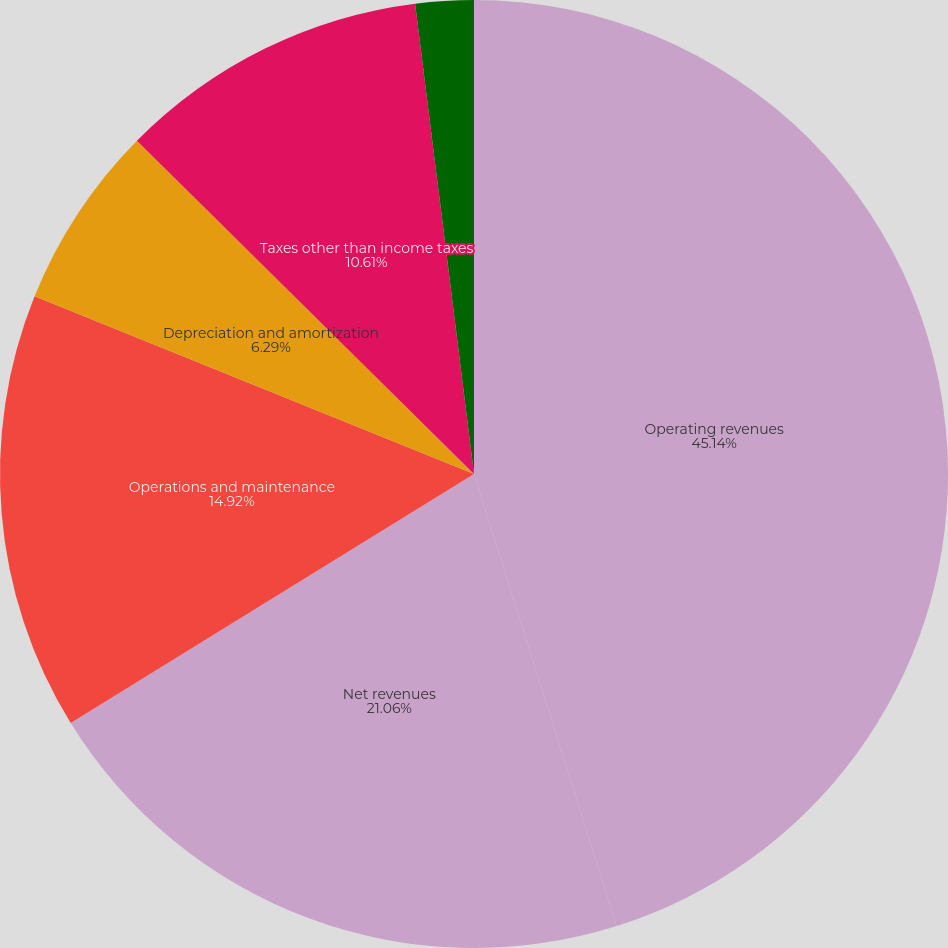<chart> <loc_0><loc_0><loc_500><loc_500><pie_chart><fcel>Operating revenues<fcel>Net revenues<fcel>Operations and maintenance<fcel>Depreciation and amortization<fcel>Taxes other than income taxes<fcel>Operating income<nl><fcel>45.13%<fcel>21.06%<fcel>14.92%<fcel>6.29%<fcel>10.61%<fcel>1.98%<nl></chart> 